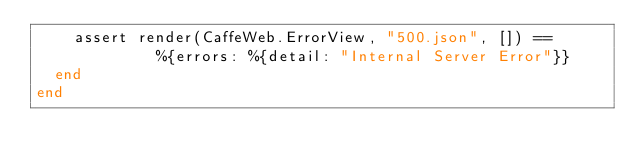Convert code to text. <code><loc_0><loc_0><loc_500><loc_500><_Elixir_>    assert render(CaffeWeb.ErrorView, "500.json", []) ==
             %{errors: %{detail: "Internal Server Error"}}
  end
end
</code> 